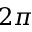<formula> <loc_0><loc_0><loc_500><loc_500>2 \pi</formula> 